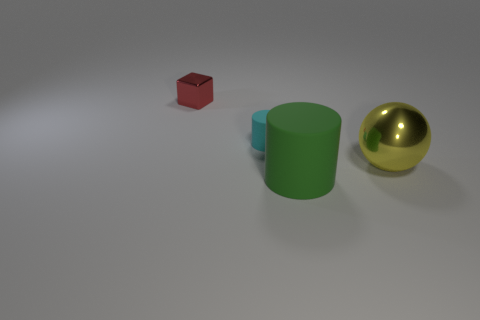Is there anything else that has the same shape as the yellow thing?
Offer a terse response. No. Do the big ball and the object that is behind the small cyan rubber cylinder have the same material?
Give a very brief answer. Yes. There is a matte object that is left of the matte object in front of the tiny object that is right of the tiny cube; what is its color?
Give a very brief answer. Cyan. What is the color of the big ball?
Provide a short and direct response. Yellow. There is a rubber object that is behind the object in front of the metallic object in front of the red shiny cube; what shape is it?
Your answer should be very brief. Cylinder. How many other things are there of the same color as the large metallic ball?
Give a very brief answer. 0. Are there more small metal objects to the left of the cyan cylinder than big green cylinders that are left of the red cube?
Make the answer very short. Yes. Are there any rubber cylinders in front of the big metal object?
Provide a short and direct response. Yes. The thing that is to the right of the small cyan matte cylinder and left of the yellow ball is made of what material?
Provide a short and direct response. Rubber. The other big matte thing that is the same shape as the cyan rubber thing is what color?
Your answer should be compact. Green. 